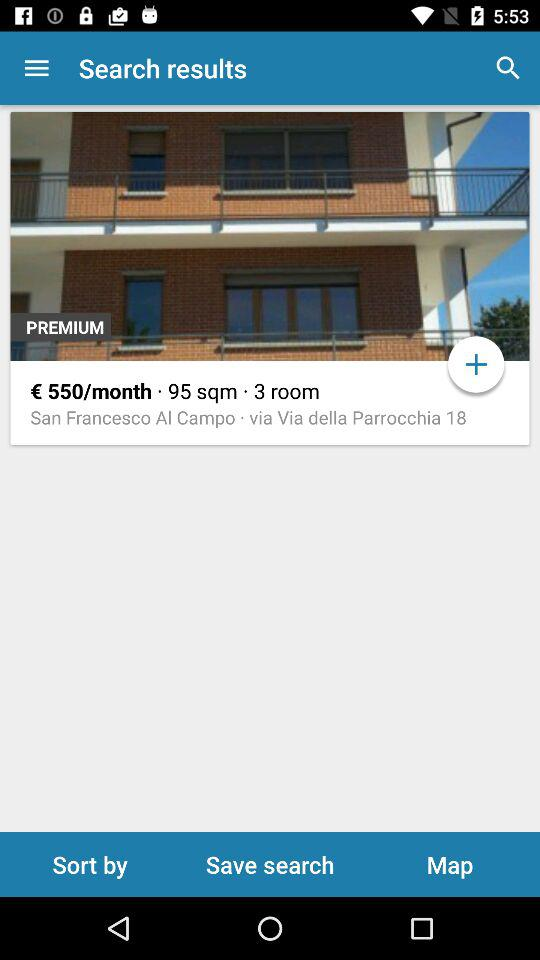How many rooms are there? There are 3 rooms. 